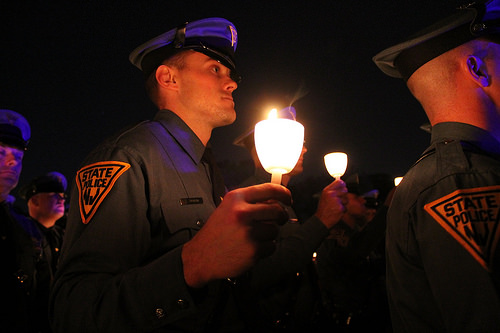<image>
Is there a hat on the candle? No. The hat is not positioned on the candle. They may be near each other, but the hat is not supported by or resting on top of the candle. Is there a cap behind the candle? No. The cap is not behind the candle. From this viewpoint, the cap appears to be positioned elsewhere in the scene. 